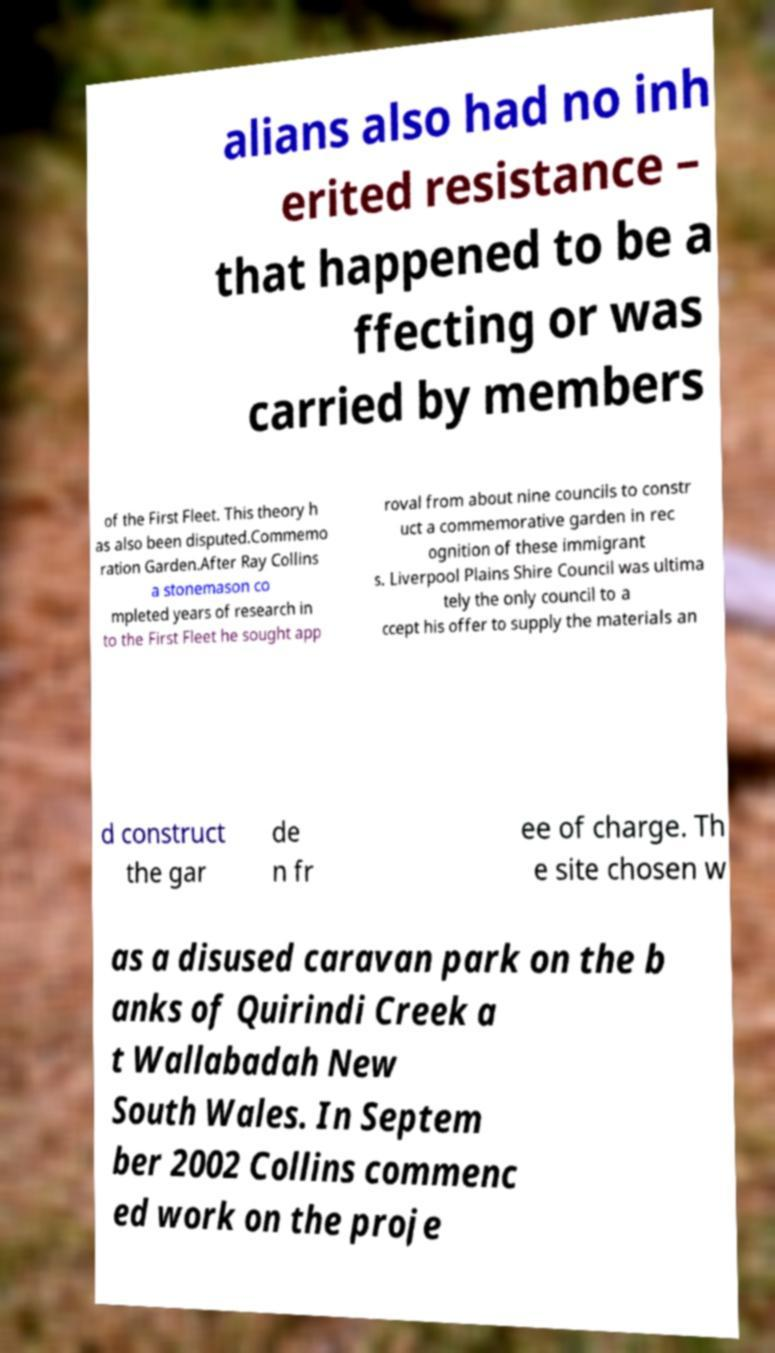What messages or text are displayed in this image? I need them in a readable, typed format. alians also had no inh erited resistance – that happened to be a ffecting or was carried by members of the First Fleet. This theory h as also been disputed.Commemo ration Garden.After Ray Collins a stonemason co mpleted years of research in to the First Fleet he sought app roval from about nine councils to constr uct a commemorative garden in rec ognition of these immigrant s. Liverpool Plains Shire Council was ultima tely the only council to a ccept his offer to supply the materials an d construct the gar de n fr ee of charge. Th e site chosen w as a disused caravan park on the b anks of Quirindi Creek a t Wallabadah New South Wales. In Septem ber 2002 Collins commenc ed work on the proje 